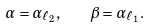Convert formula to latex. <formula><loc_0><loc_0><loc_500><loc_500>\alpha = \alpha _ { \ell _ { 2 } } , \quad \beta = \alpha _ { \ell _ { 1 } } .</formula> 